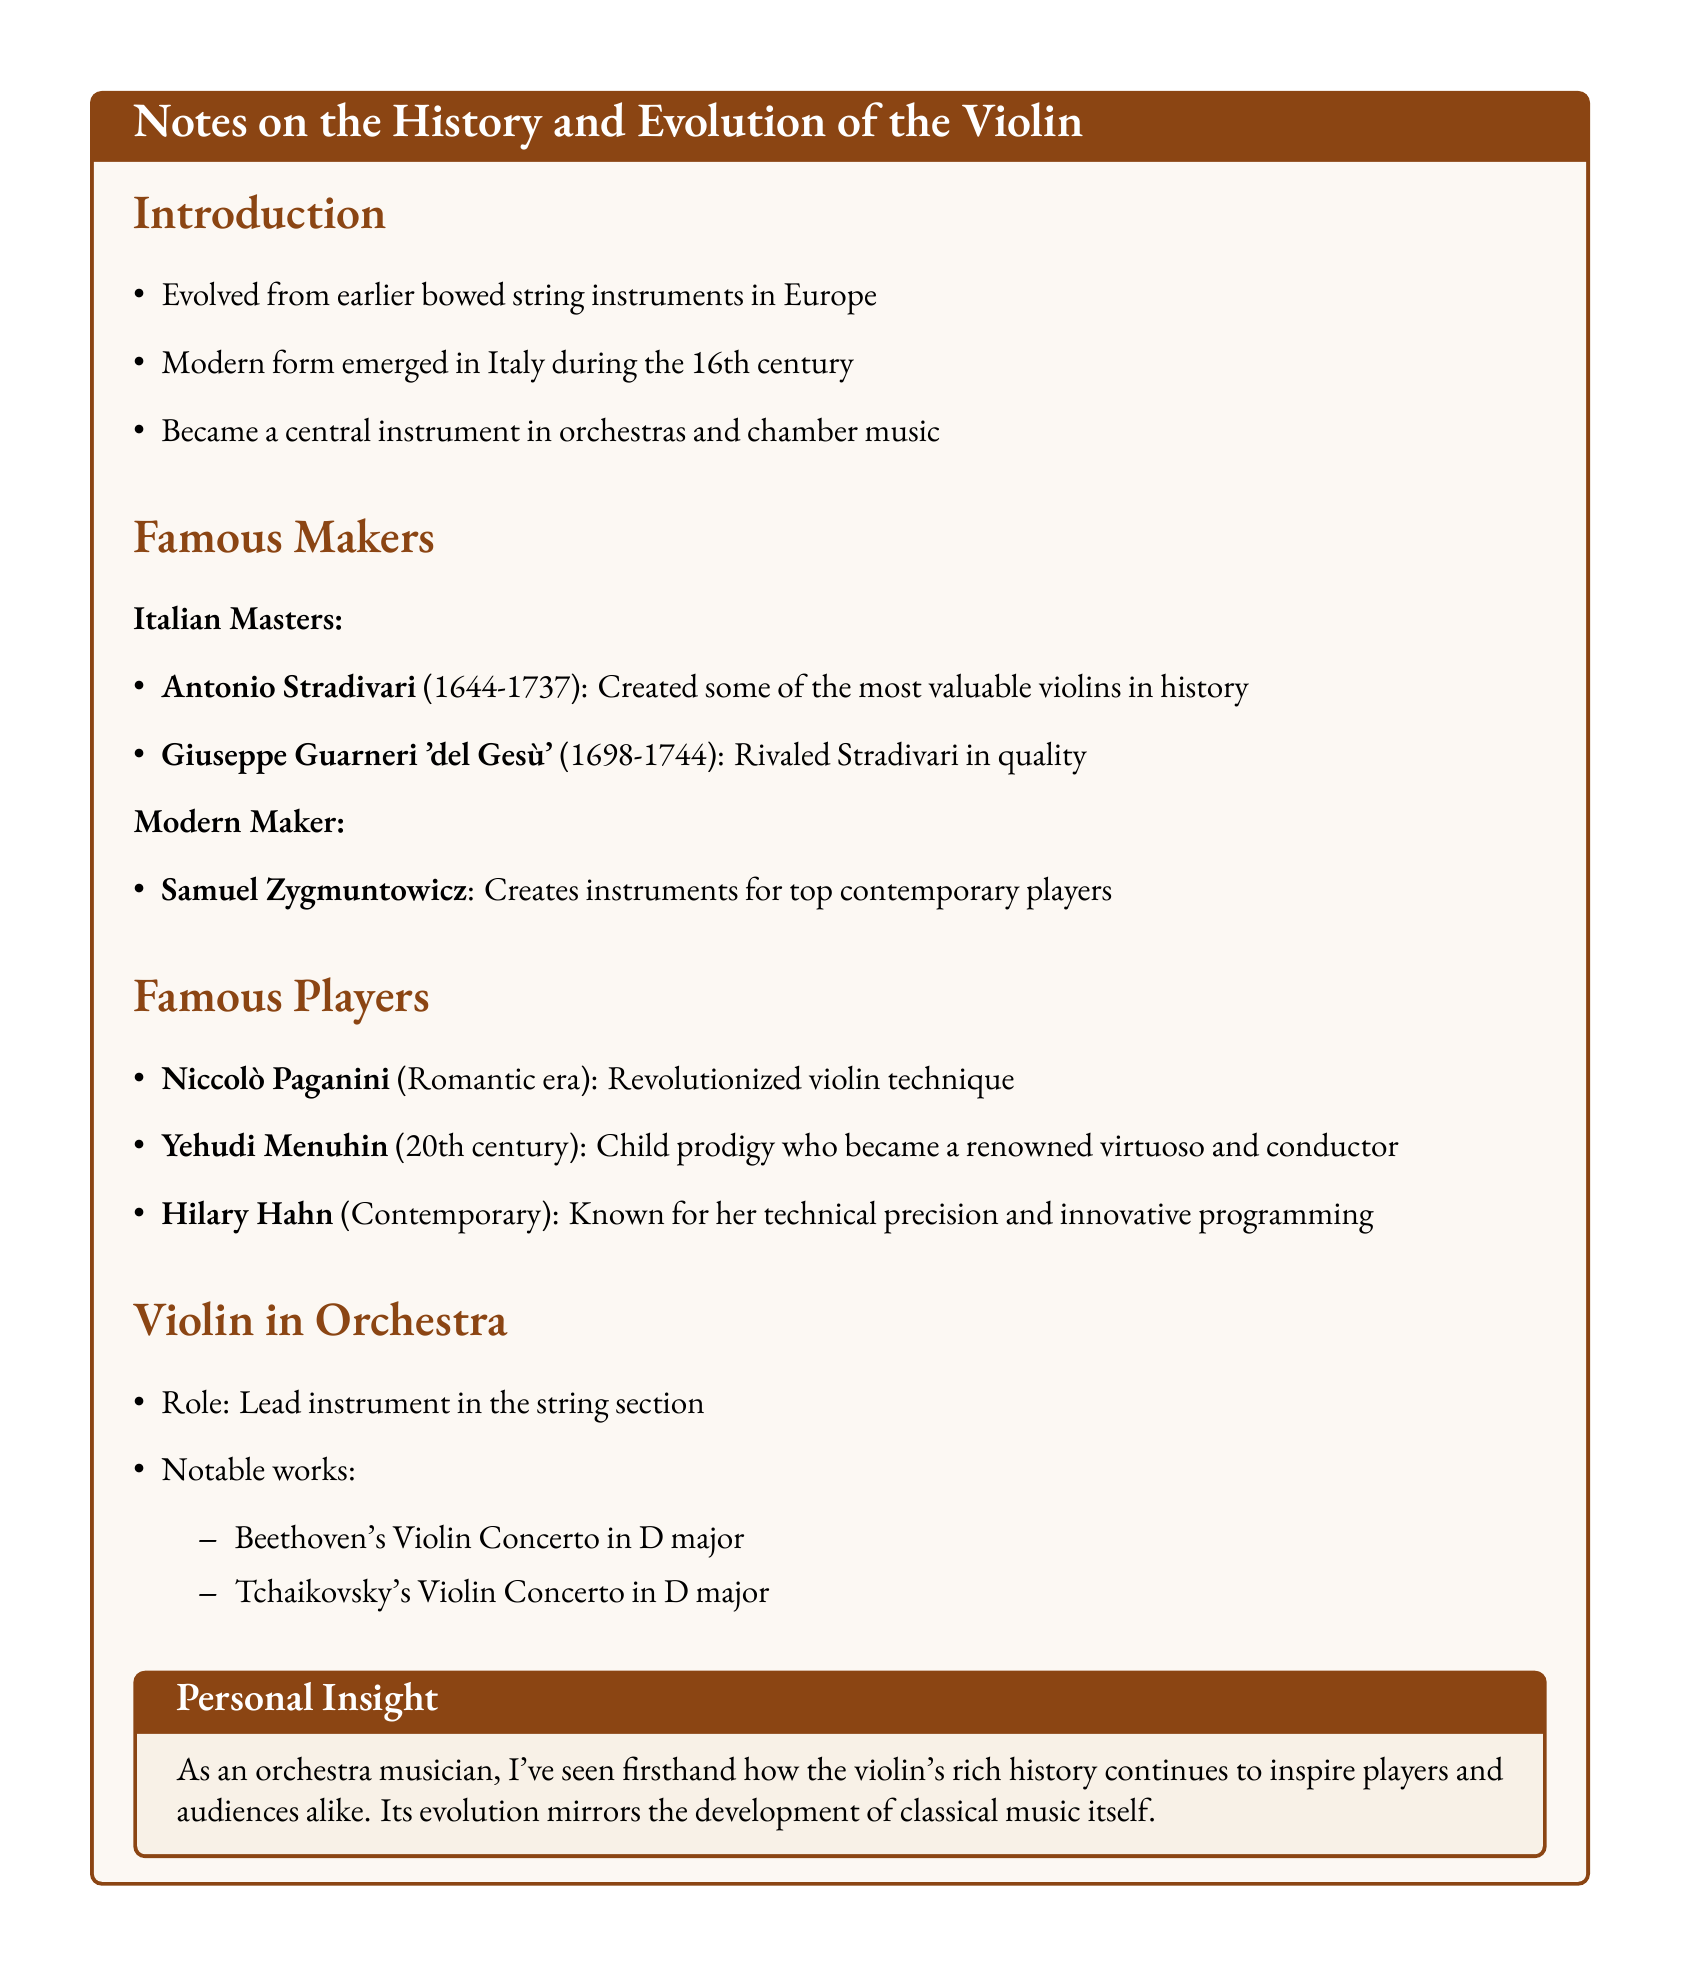What period did Antonio Stradivari live? Antonio Stradivari lived from 1644 to 1737, which is noted in the section about famous makers.
Answer: 1644-1737 Who is known as "del Gesù"? In the document, Giuseppe Guarneri is referred to as "del Gesù," highlighting his notable name in violin making.
Answer: Giuseppe Guarneri What is the role of the violin in the orchestra? The document states that the violin serves as the lead instrument in the string section of the orchestra.
Answer: Lead instrument Name a famous work by Beethoven that features the violin. One of the notable works listed is Beethoven's Violin Concerto in D major, which showcases the violin's importance in classical music.
Answer: Beethoven's Violin Concerto in D major Which contemporary player is mentioned in the notes? The document specifically mentions Hilary Hahn as a contemporary player known for her technical precision.
Answer: Hilary Hahn What notable fact is associated with Samuel Zygmuntowicz? Samual Zygmuntowicz is mentioned as a maker who creates instruments for top contemporary players.
Answer: Creates instruments for top contemporary players What did Niccolò Paganini contribute to violin playing? The notes indicate that Niccolò Paganini revolutionized violin technique during the Romantic era.
Answer: Revolutionized violin technique What era does Yehudi Menuhin belong to? The document specifies that Yehudi Menuhin is associated with the 20th century era in music.
Answer: 20th century 